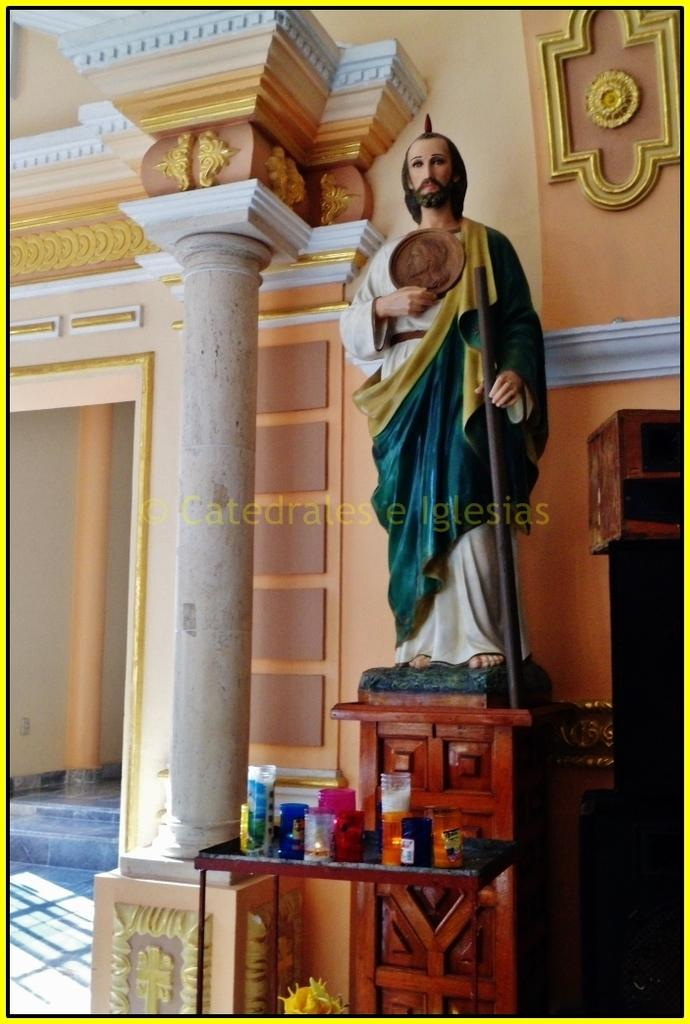What is the main subject of the image? There is a statue of a man in the image. What objects can be seen on a table in the image? There are candles on a table in the image. What architectural feature is present in the image? There is a pillar in the image. What can be used to enter or exit a space in the image? There is an entrance in the image. What type of decoration is present on the wall in the image? There are designs on the wall in the image. How many books are stacked on the statue in the image? There are no books present in the image; the main subject is a statue of a man. 